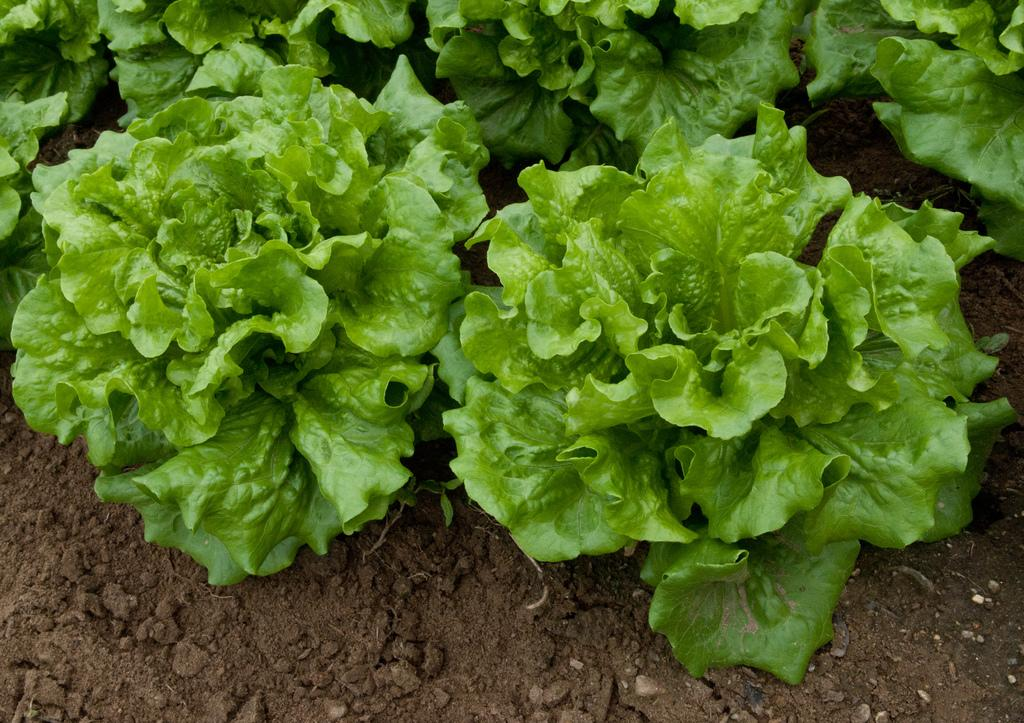What type of plants are in the image? The image contains lettuce plants. What can be seen at the bottom of the image? Mud is visible at the bottom of the image. What type of blade can be seen cutting through the lettuce plants in the image? There is no blade present in the image, and the lettuce plants are not being cut. What emotion is being expressed by the lettuce plants in the image? Lettuce plants do not have emotions, so it is not possible to determine an emotion being expressed. 